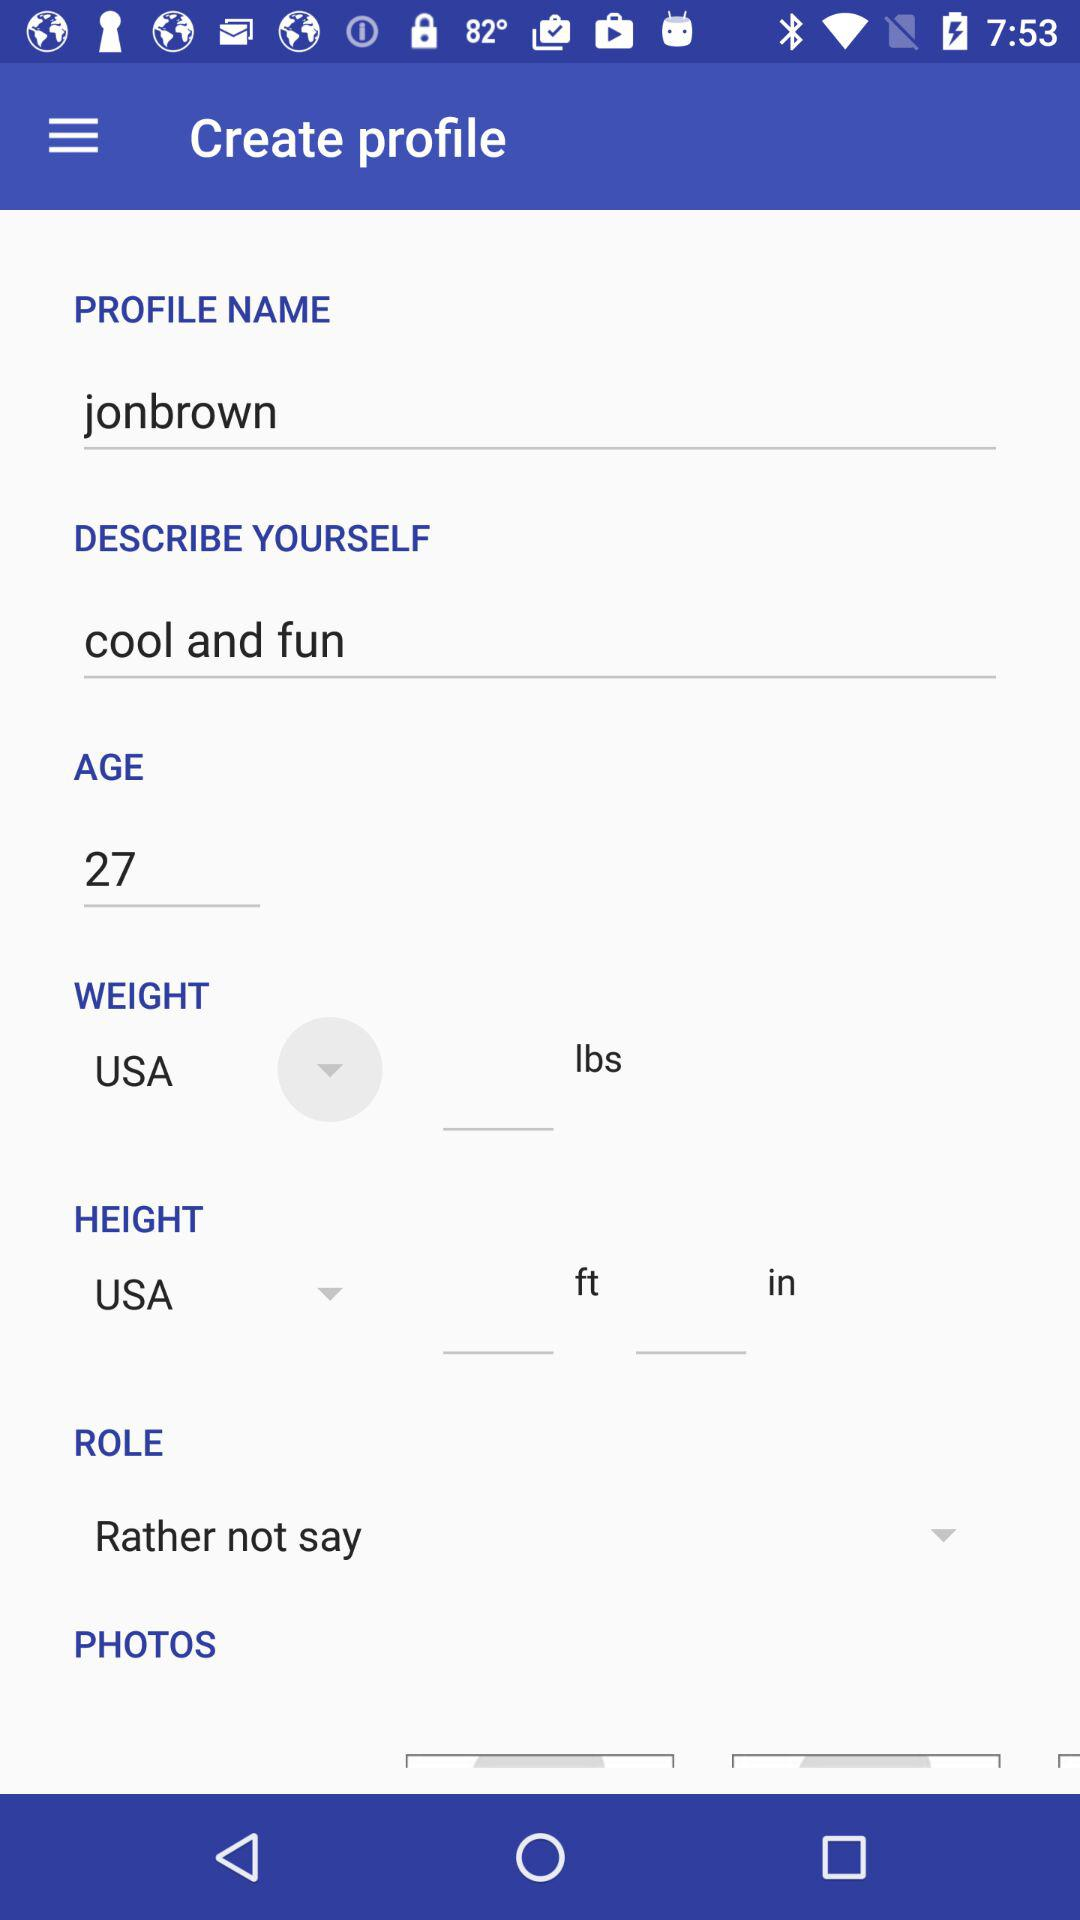What is the user's personality like? The user's personality is cool and funny. 